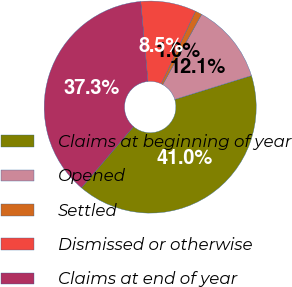Convert chart. <chart><loc_0><loc_0><loc_500><loc_500><pie_chart><fcel>Claims at beginning of year<fcel>Opened<fcel>Settled<fcel>Dismissed or otherwise<fcel>Claims at end of year<nl><fcel>41.03%<fcel>12.15%<fcel>1.03%<fcel>8.46%<fcel>37.34%<nl></chart> 